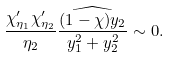Convert formula to latex. <formula><loc_0><loc_0><loc_500><loc_500>\frac { \chi _ { \eta _ { 1 } } ^ { \prime } \chi _ { \eta _ { 2 } } ^ { \prime } } { \eta _ { 2 } } \widehat { \frac { ( 1 - \chi ) y _ { 2 } } { y _ { 1 } ^ { 2 } + y _ { 2 } ^ { 2 } } } \sim 0 .</formula> 